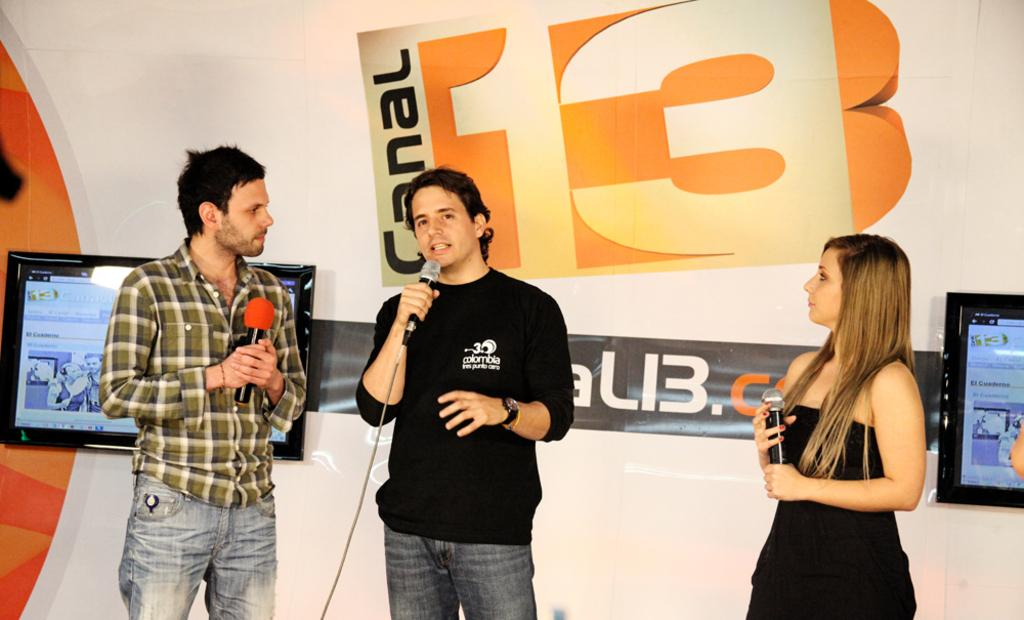How many people are in the image? There are people in the image, but the exact number is not specified. What are the people doing in the image? The people are standing and holding mics in their hands. What can be seen in the background of the image? There are display screens and an advertisement in the background of the image. What type of straw is being used by the dolls in the image? There are no dolls present in the image, and therefore no straws can be observed. What kind of guide is assisting the people in the image? There is no guide mentioned or visible in the image. 